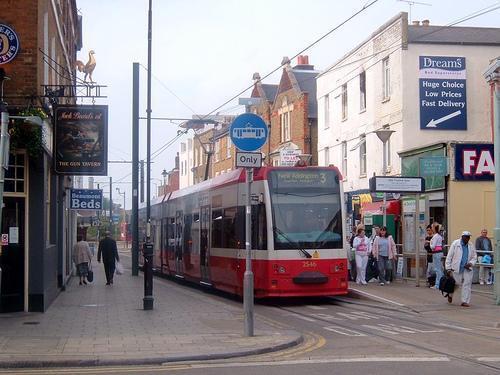How many people are seen on the leftmost side of the photo?
Give a very brief answer. 2. 